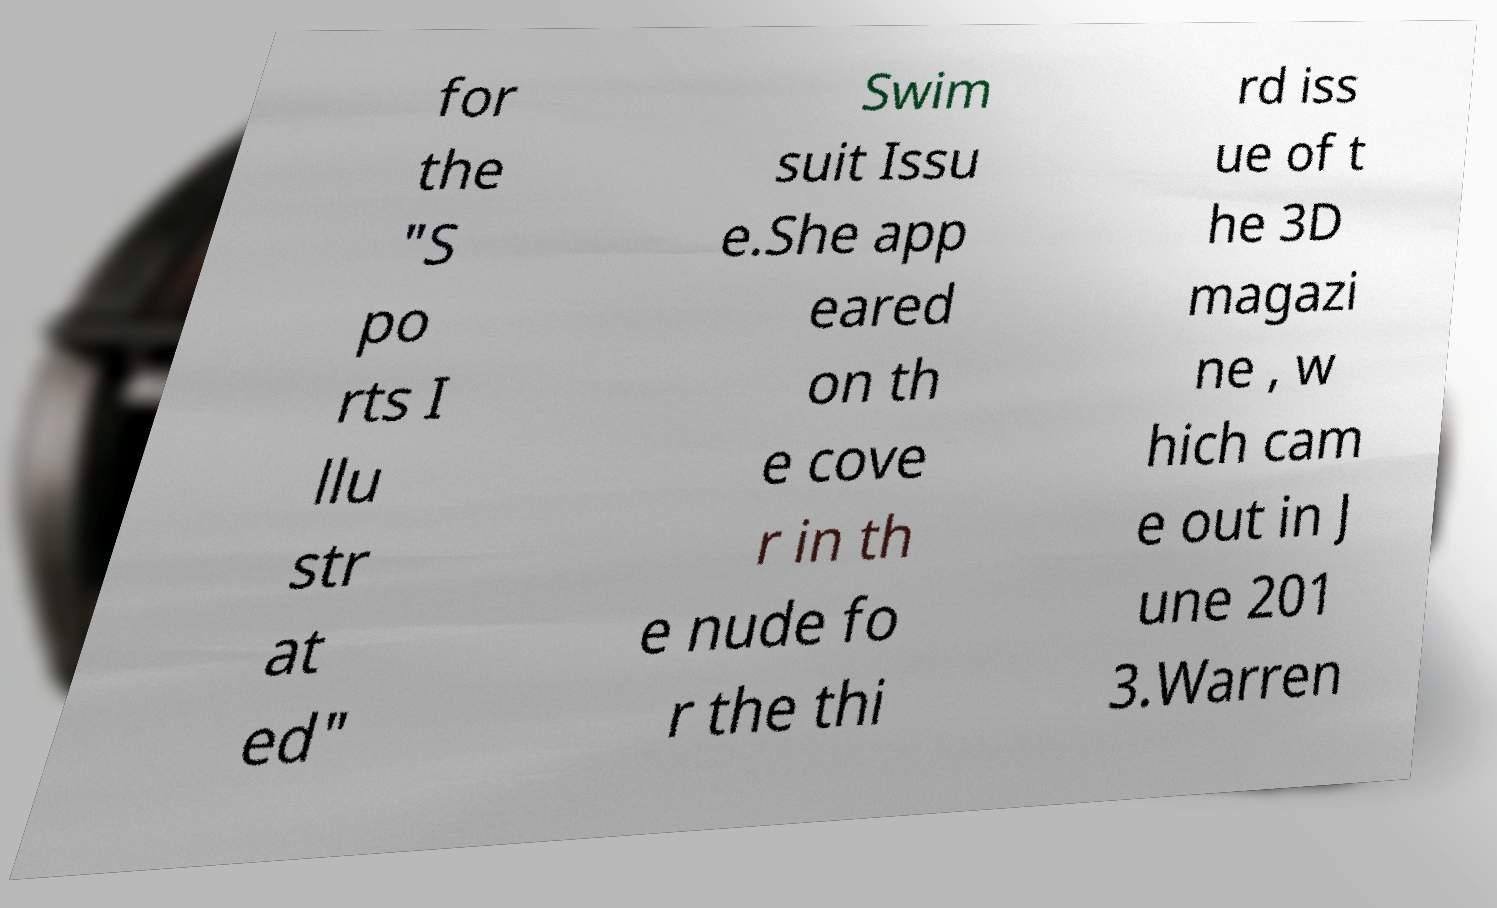Can you read and provide the text displayed in the image?This photo seems to have some interesting text. Can you extract and type it out for me? for the "S po rts I llu str at ed" Swim suit Issu e.She app eared on th e cove r in th e nude fo r the thi rd iss ue of t he 3D magazi ne , w hich cam e out in J une 201 3.Warren 